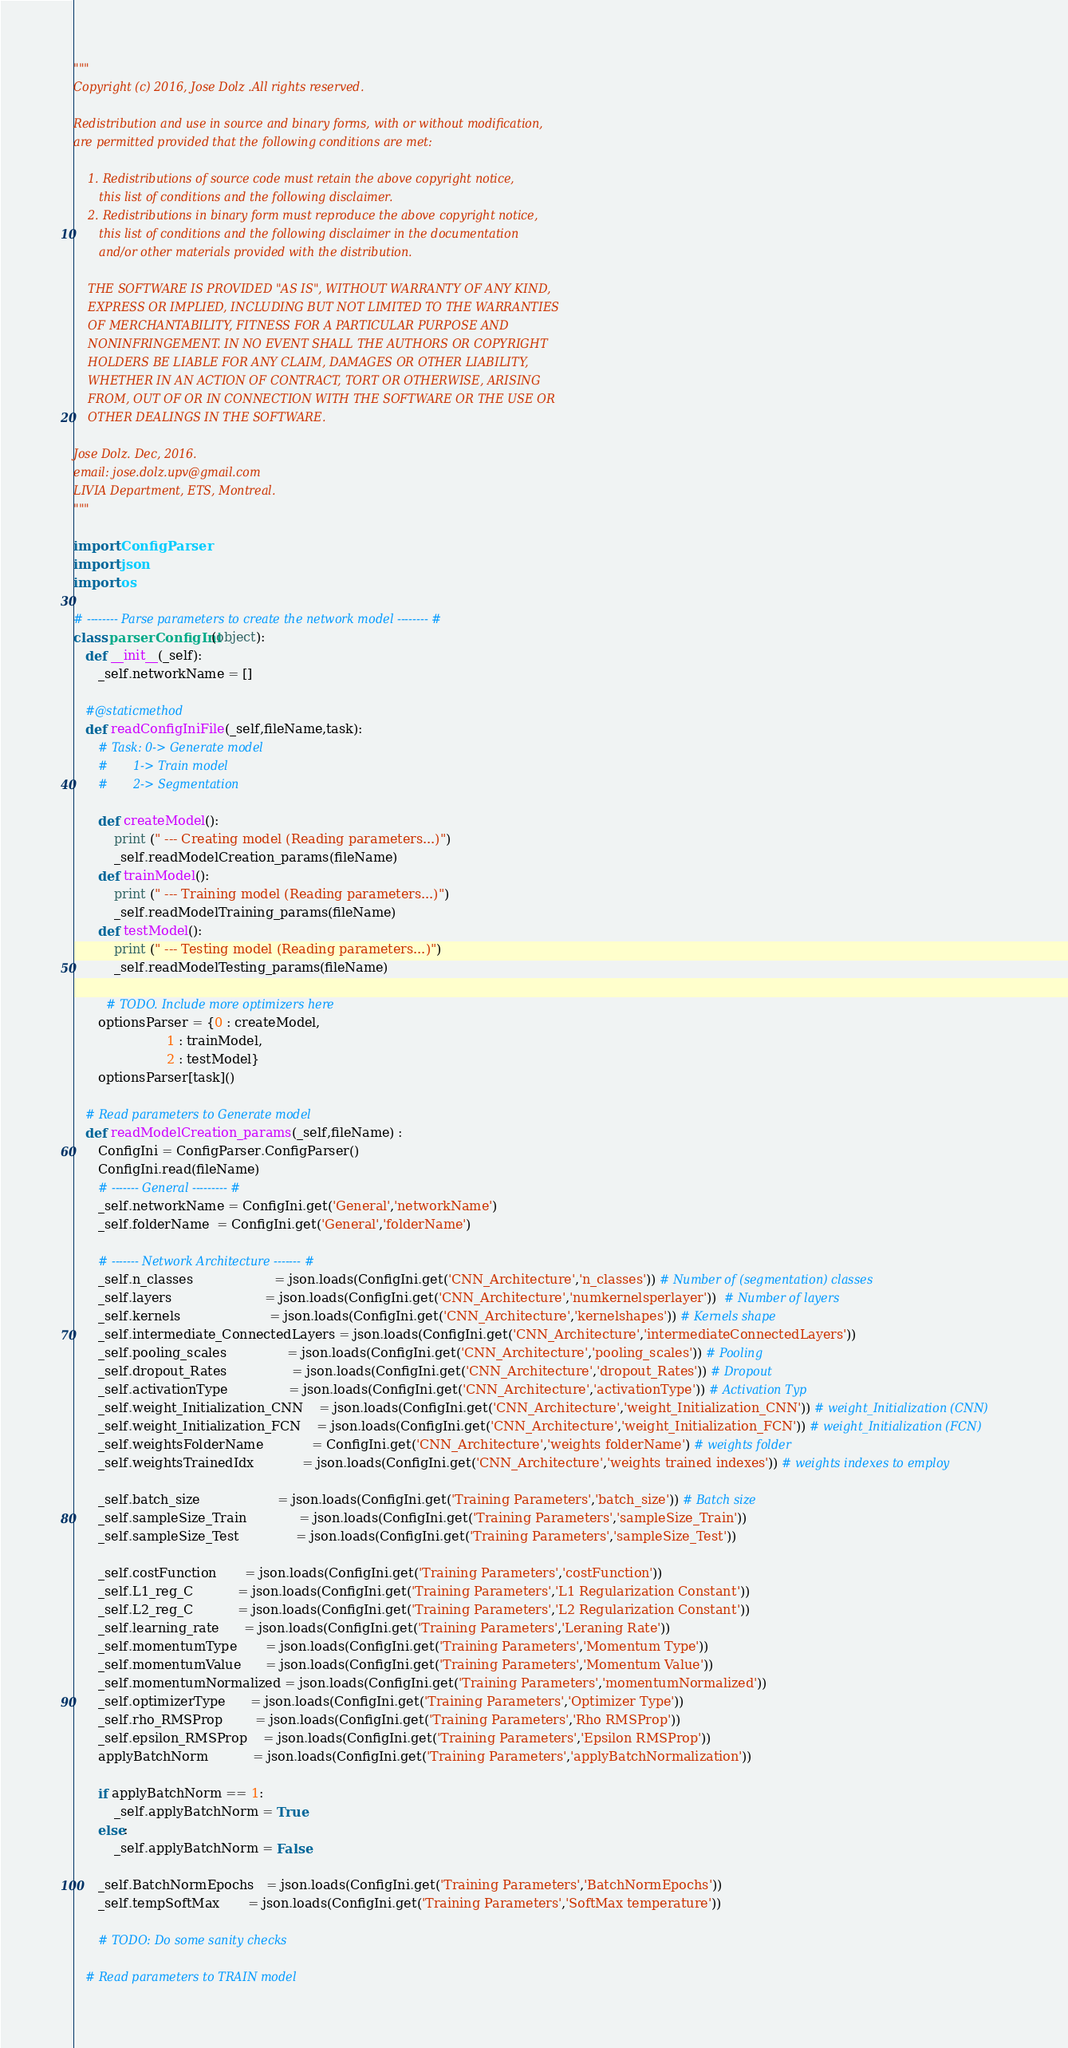Convert code to text. <code><loc_0><loc_0><loc_500><loc_500><_Python_>""" 
Copyright (c) 2016, Jose Dolz .All rights reserved.

Redistribution and use in source and binary forms, with or without modification,
are permitted provided that the following conditions are met:

    1. Redistributions of source code must retain the above copyright notice,
       this list of conditions and the following disclaimer.
    2. Redistributions in binary form must reproduce the above copyright notice,
       this list of conditions and the following disclaimer in the documentation
       and/or other materials provided with the distribution.

    THE SOFTWARE IS PROVIDED "AS IS", WITHOUT WARRANTY OF ANY KIND,
    EXPRESS OR IMPLIED, INCLUDING BUT NOT LIMITED TO THE WARRANTIES
    OF MERCHANTABILITY, FITNESS FOR A PARTICULAR PURPOSE AND
    NONINFRINGEMENT. IN NO EVENT SHALL THE AUTHORS OR COPYRIGHT
    HOLDERS BE LIABLE FOR ANY CLAIM, DAMAGES OR OTHER LIABILITY,
    WHETHER IN AN ACTION OF CONTRACT, TORT OR OTHERWISE, ARISING
    FROM, OUT OF OR IN CONNECTION WITH THE SOFTWARE OR THE USE OR
    OTHER DEALINGS IN THE SOFTWARE.

Jose Dolz. Dec, 2016.
email: jose.dolz.upv@gmail.com
LIVIA Department, ETS, Montreal.
"""
 
import ConfigParser
import json
import os

# -------- Parse parameters to create the network model -------- #
class parserConfigIni(object):
   def __init__(_self):
      _self.networkName = []
      
   #@staticmethod
   def readConfigIniFile(_self,fileName,task):
      # Task: 0-> Generate model
      #       1-> Train model
      #       2-> Segmentation

      def createModel():
          print (" --- Creating model (Reading parameters...)")
          _self.readModelCreation_params(fileName)
      def trainModel():
          print (" --- Training model (Reading parameters...)")
          _self.readModelTraining_params(fileName)
      def testModel():
          print (" --- Testing model (Reading parameters...)")
          _self.readModelTesting_params(fileName)
       
        # TODO. Include more optimizers here
      optionsParser = {0 : createModel,
                       1 : trainModel,
                       2 : testModel}
      optionsParser[task]()

   # Read parameters to Generate model
   def readModelCreation_params(_self,fileName) :
      ConfigIni = ConfigParser.ConfigParser()
      ConfigIni.read(fileName)
      # ------- General --------- #
      _self.networkName = ConfigIni.get('General','networkName')
      _self.folderName  = ConfigIni.get('General','folderName')
      
      # ------- Network Architecture ------- #
      _self.n_classes                    = json.loads(ConfigIni.get('CNN_Architecture','n_classes')) # Number of (segmentation) classes
      _self.layers                       = json.loads(ConfigIni.get('CNN_Architecture','numkernelsperlayer'))  # Number of layers
      _self.kernels                      = json.loads(ConfigIni.get('CNN_Architecture','kernelshapes')) # Kernels shape
      _self.intermediate_ConnectedLayers = json.loads(ConfigIni.get('CNN_Architecture','intermediateConnectedLayers'))
      _self.pooling_scales               = json.loads(ConfigIni.get('CNN_Architecture','pooling_scales')) # Pooling
      _self.dropout_Rates                = json.loads(ConfigIni.get('CNN_Architecture','dropout_Rates')) # Dropout
      _self.activationType               = json.loads(ConfigIni.get('CNN_Architecture','activationType')) # Activation Typ
      _self.weight_Initialization_CNN    = json.loads(ConfigIni.get('CNN_Architecture','weight_Initialization_CNN')) # weight_Initialization (CNN)
      _self.weight_Initialization_FCN    = json.loads(ConfigIni.get('CNN_Architecture','weight_Initialization_FCN')) # weight_Initialization (FCN)
      _self.weightsFolderName            = ConfigIni.get('CNN_Architecture','weights folderName') # weights folder
      _self.weightsTrainedIdx            = json.loads(ConfigIni.get('CNN_Architecture','weights trained indexes')) # weights indexes to employ

      _self.batch_size                   = json.loads(ConfigIni.get('Training Parameters','batch_size')) # Batch size
      _self.sampleSize_Train             = json.loads(ConfigIni.get('Training Parameters','sampleSize_Train'))
      _self.sampleSize_Test              = json.loads(ConfigIni.get('Training Parameters','sampleSize_Test'))

      _self.costFunction       = json.loads(ConfigIni.get('Training Parameters','costFunction'))
      _self.L1_reg_C           = json.loads(ConfigIni.get('Training Parameters','L1 Regularization Constant'))
      _self.L2_reg_C           = json.loads(ConfigIni.get('Training Parameters','L2 Regularization Constant'))
      _self.learning_rate      = json.loads(ConfigIni.get('Training Parameters','Leraning Rate'))
      _self.momentumType       = json.loads(ConfigIni.get('Training Parameters','Momentum Type'))
      _self.momentumValue      = json.loads(ConfigIni.get('Training Parameters','Momentum Value'))
      _self.momentumNormalized = json.loads(ConfigIni.get('Training Parameters','momentumNormalized'))
      _self.optimizerType      = json.loads(ConfigIni.get('Training Parameters','Optimizer Type'))
      _self.rho_RMSProp        = json.loads(ConfigIni.get('Training Parameters','Rho RMSProp'))
      _self.epsilon_RMSProp    = json.loads(ConfigIni.get('Training Parameters','Epsilon RMSProp'))
      applyBatchNorm           = json.loads(ConfigIni.get('Training Parameters','applyBatchNormalization'))

      if applyBatchNorm == 1:
          _self.applyBatchNorm = True
      else:
          _self.applyBatchNorm = False
      
      _self.BatchNormEpochs   = json.loads(ConfigIni.get('Training Parameters','BatchNormEpochs'))
      _self.tempSoftMax       = json.loads(ConfigIni.get('Training Parameters','SoftMax temperature'))

      # TODO: Do some sanity checks

   # Read parameters to TRAIN model</code> 